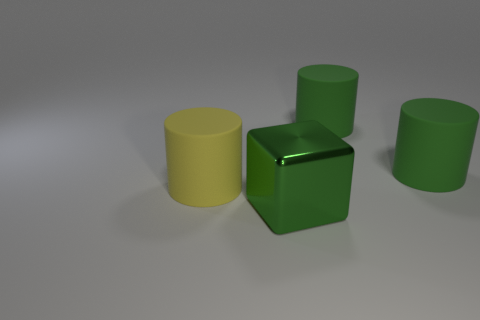Add 1 big gray metal balls. How many objects exist? 5 Subtract 1 cylinders. How many cylinders are left? 2 Subtract all green matte cylinders. How many cylinders are left? 1 Subtract all cubes. How many objects are left? 3 Subtract all yellow matte cylinders. Subtract all big red rubber cubes. How many objects are left? 3 Add 1 blocks. How many blocks are left? 2 Add 4 small green metal cubes. How many small green metal cubes exist? 4 Subtract all green cylinders. How many cylinders are left? 1 Subtract 0 brown cylinders. How many objects are left? 4 Subtract all blue cylinders. Subtract all cyan balls. How many cylinders are left? 3 